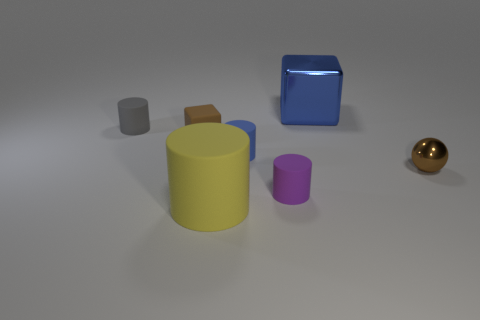Subtract all purple cylinders. How many cylinders are left? 3 Add 1 tiny red rubber cylinders. How many objects exist? 8 Subtract all gray cylinders. How many cylinders are left? 3 Subtract all spheres. How many objects are left? 6 Add 1 brown blocks. How many brown blocks exist? 2 Subtract 1 purple cylinders. How many objects are left? 6 Subtract all cyan blocks. Subtract all purple cylinders. How many blocks are left? 2 Subtract all brown cubes. Subtract all large yellow cylinders. How many objects are left? 5 Add 6 gray cylinders. How many gray cylinders are left? 7 